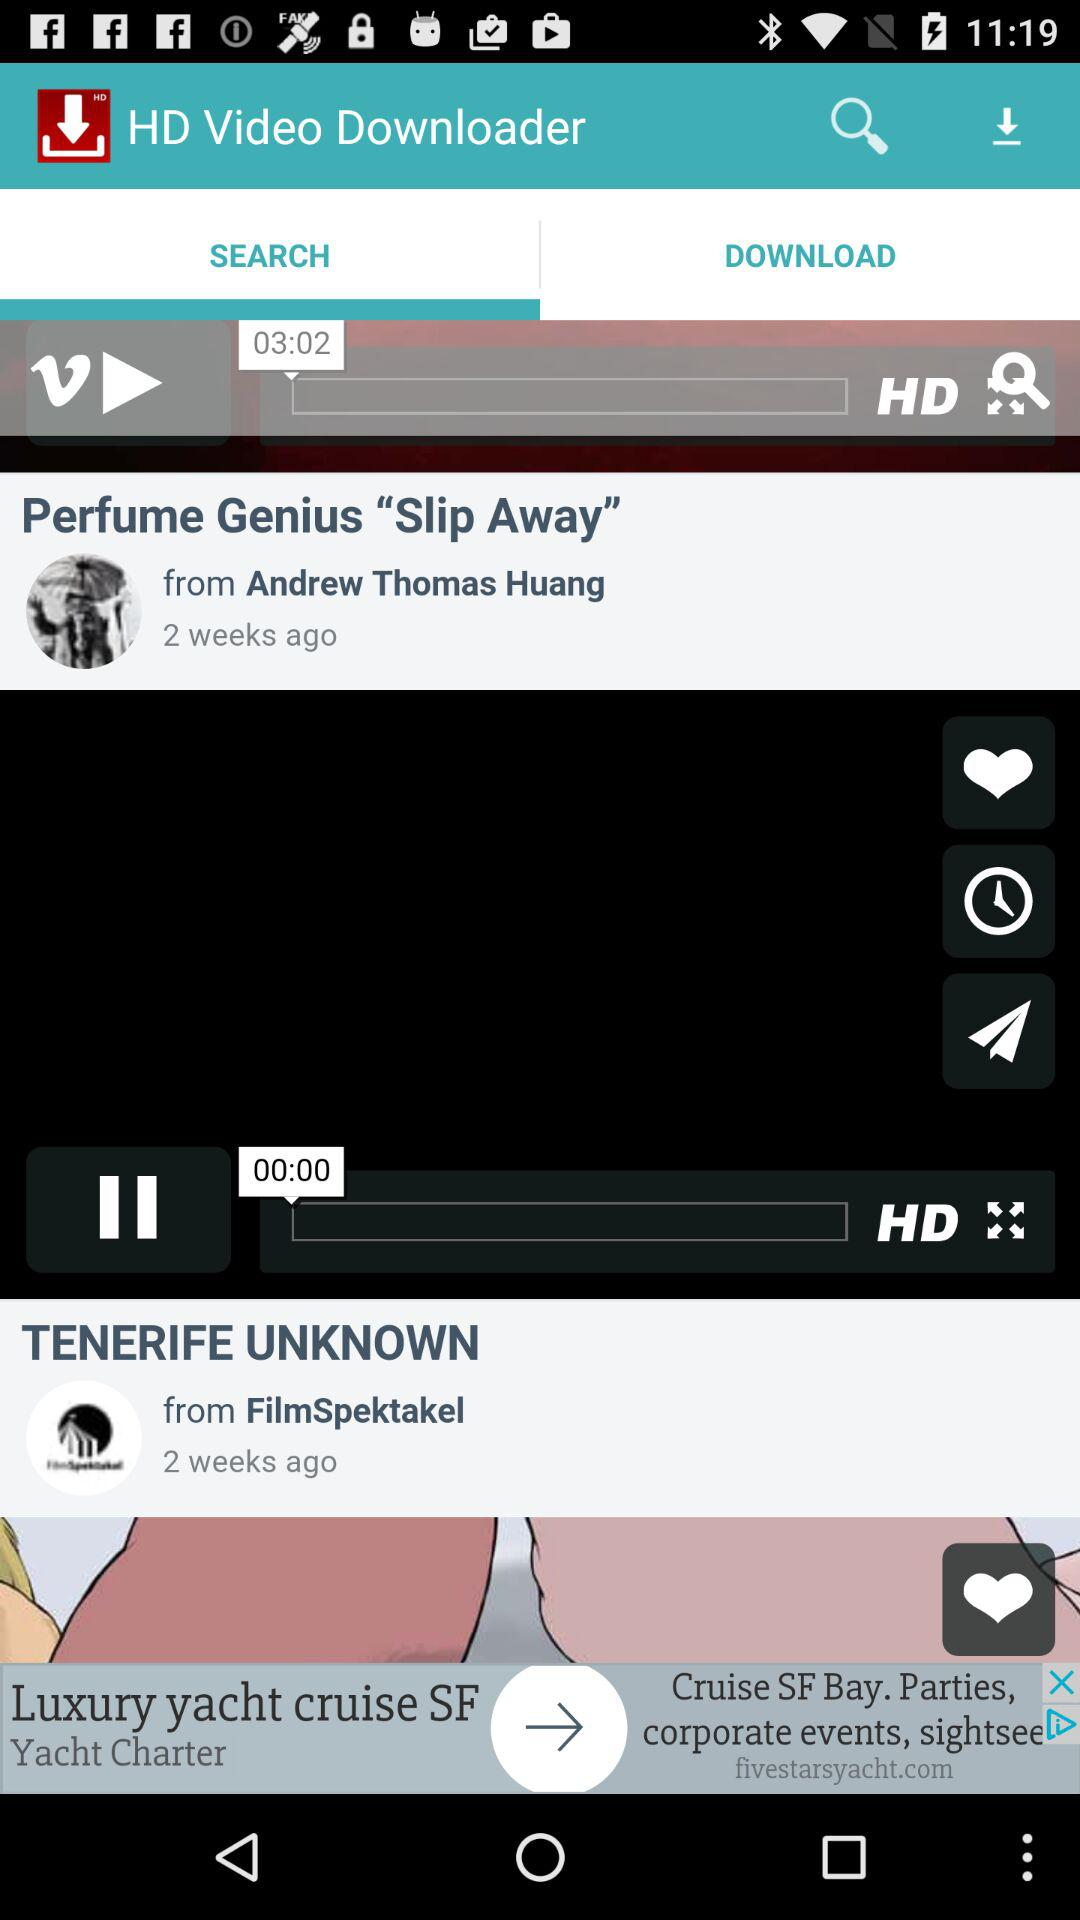What is the time shown for the question?
When the provided information is insufficient, respond with <no answer>. <no answer> 